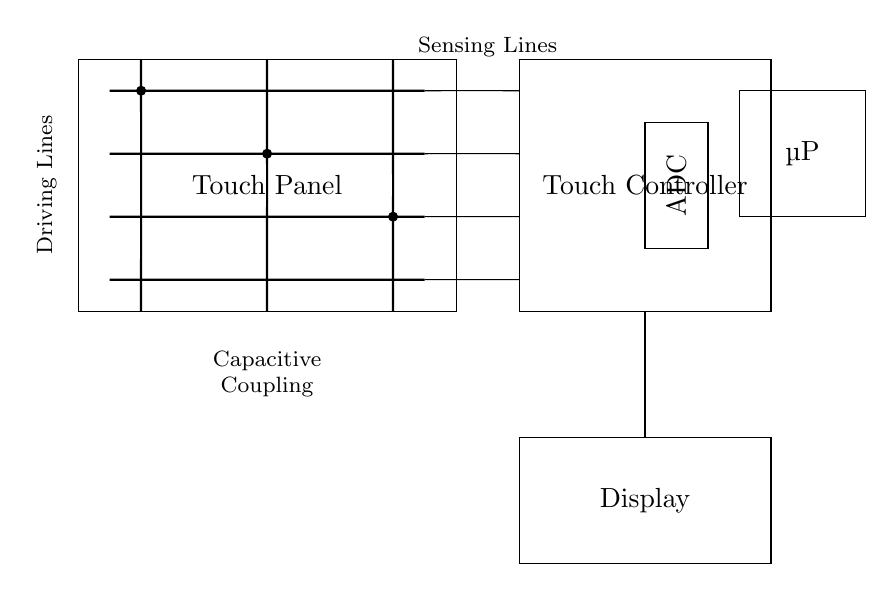What type of components are used for sensing? The circuit diagram includes capacitive coupling components for sensing, indicated by the circ nodes placed at specific electrodes. These components detect the changes in capacitance when a finger or conductive object approaches.
Answer: Capacitive coupling How many driving electrodes are present? By counting the vertical lines at the top section of the diagram, there are three distinct driving electrodes noted. Each is represented by a short line connecting from the top to the bottom of the touch panel.
Answer: Three What is the role of the ADC in this circuit? The ADC (Analog-to-Digital Converter) converts the analog capacitance signals received from the sensing electrodes into a digital format, making it usable for processing by the microprocessor. Hence, its role is crucial for interpreting the signals from the touch panel.
Answer: Conversion What is the purpose of the microprocessor in the circuit? The microprocessor processes the digital signals received from the ADC, making decisions based on user input detected by the touch panel. It coordinates between the input (touch signals) and output (display action), handling the overall responsiveness of the touchscreen interface.
Answer: Processing How are the sensing electrodes connected to the touch controller? The sensing electrodes are connected through short lines that lead directly to the touch controller interface, indicating a direct communication path for signal processing. This connection ensures that the detected changes in capacitance can be communicated to the controller for further action.
Answer: Directly What might happen if a driving electrode is not connected properly? If a driving electrode is not connected, it would fail to generate the necessary electric field required for detecting touch, leading to potential non-responsiveness of the touchscreen interface. The lack of a complete connection disrupts the sensing mechanism entirely.
Answer: Non-responsiveness 